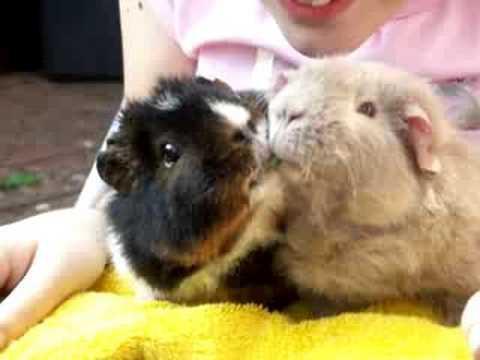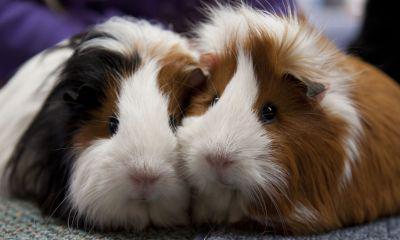The first image is the image on the left, the second image is the image on the right. For the images displayed, is the sentence "Each image shows two side-by-side guinea pigs." factually correct? Answer yes or no. Yes. The first image is the image on the left, the second image is the image on the right. For the images displayed, is the sentence "The right image contains exactly one rodent." factually correct? Answer yes or no. No. 